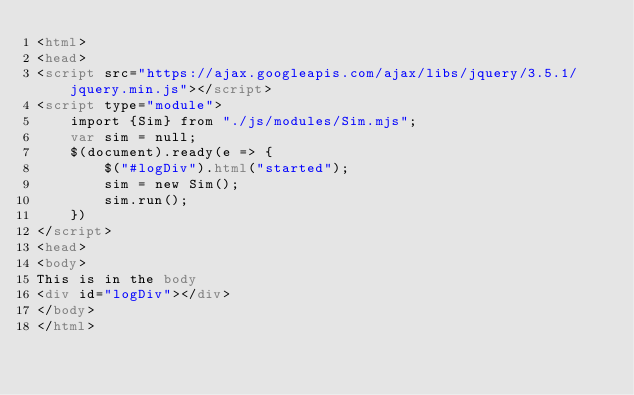<code> <loc_0><loc_0><loc_500><loc_500><_HTML_><html>
<head>
<script src="https://ajax.googleapis.com/ajax/libs/jquery/3.5.1/jquery.min.js"></script>
<script type="module">
    import {Sim} from "./js/modules/Sim.mjs";
    var sim = null;
    $(document).ready(e => {
        $("#logDiv").html("started");
        sim = new Sim();
        sim.run();
    })
</script>
<head>
<body>
This is in the body
<div id="logDiv"></div>
</body>
</html></code> 